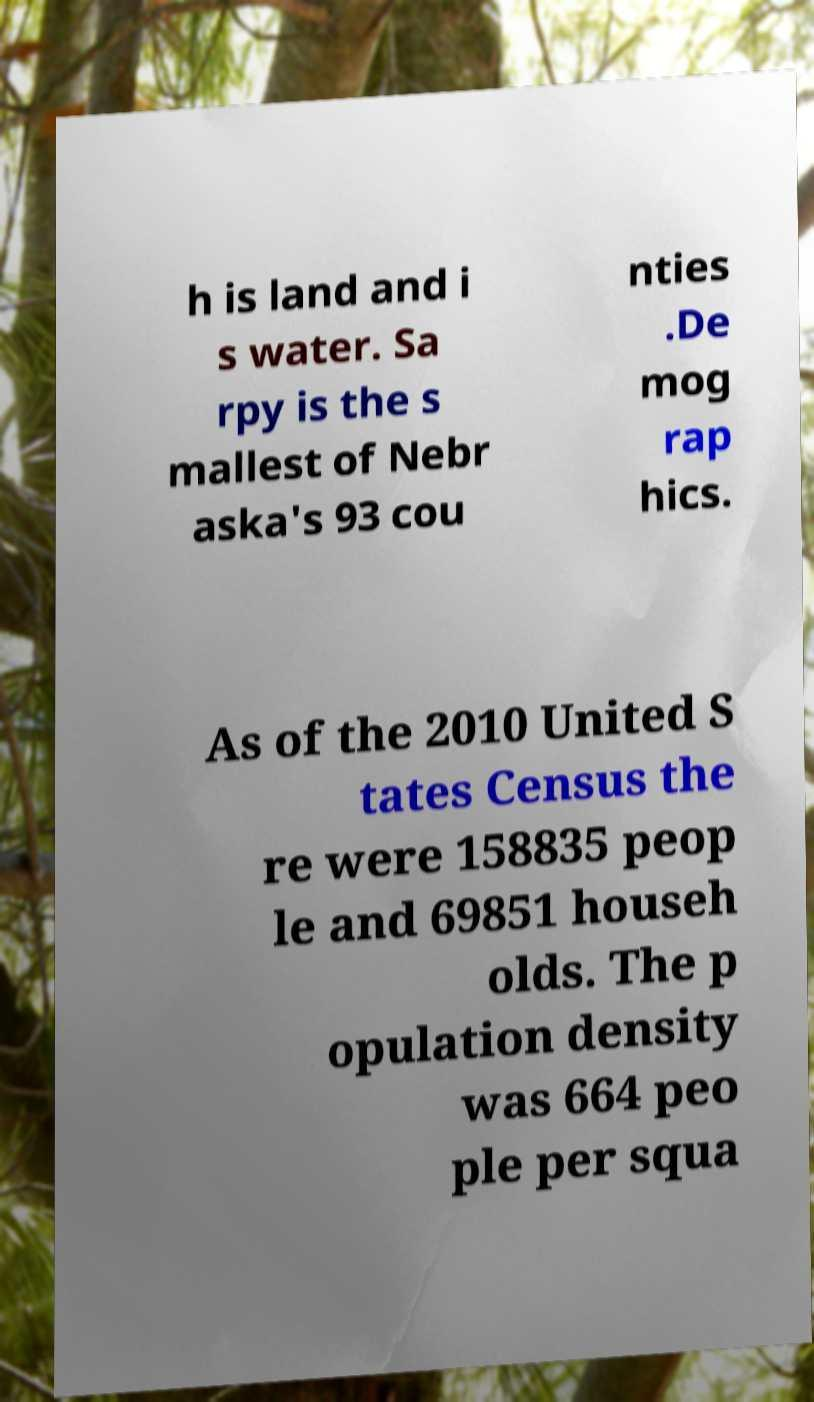Please read and relay the text visible in this image. What does it say? h is land and i s water. Sa rpy is the s mallest of Nebr aska's 93 cou nties .De mog rap hics. As of the 2010 United S tates Census the re were 158835 peop le and 69851 househ olds. The p opulation density was 664 peo ple per squa 